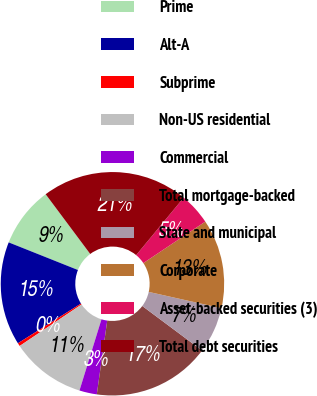Convert chart. <chart><loc_0><loc_0><loc_500><loc_500><pie_chart><fcel>Prime<fcel>Alt-A<fcel>Subprime<fcel>Non-US residential<fcel>Commercial<fcel>Total mortgage-backed<fcel>State and municipal<fcel>Corporate<fcel>Asset-backed securities (3)<fcel>Total debt securities<nl><fcel>8.76%<fcel>14.98%<fcel>0.46%<fcel>10.83%<fcel>2.53%<fcel>17.05%<fcel>6.68%<fcel>12.9%<fcel>4.61%<fcel>21.2%<nl></chart> 